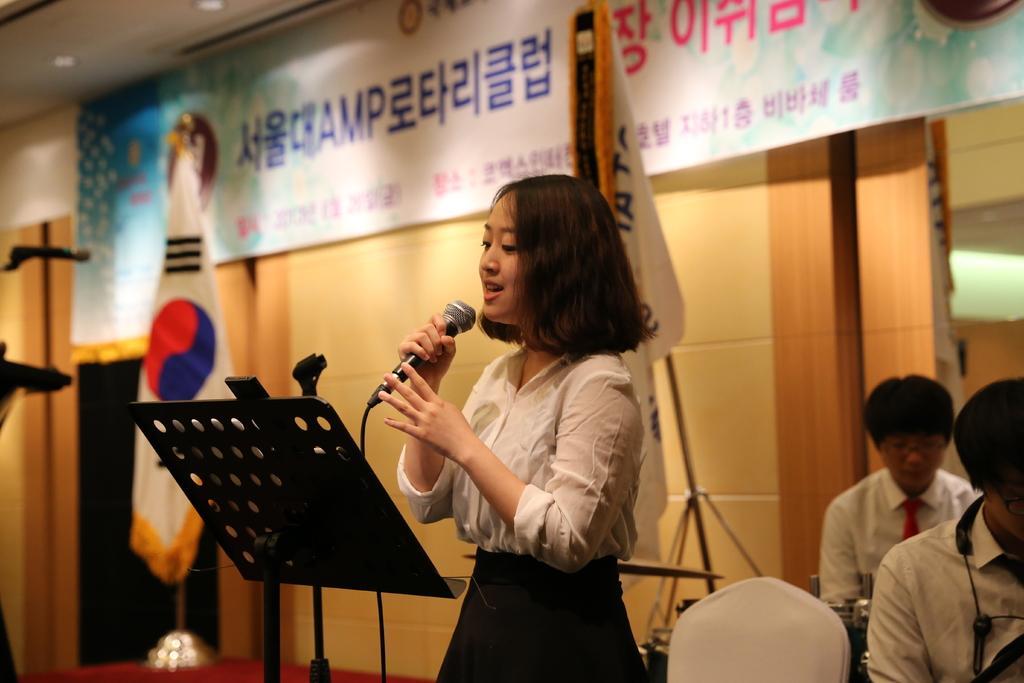In one or two sentences, can you explain what this image depicts? In this image, we can see a woman is singing and holding a microphone. Here we can see stands, rods, microphone, flags. On the right side of the image, we can see few people and some objects. Background there is a wall, banners and black object. 